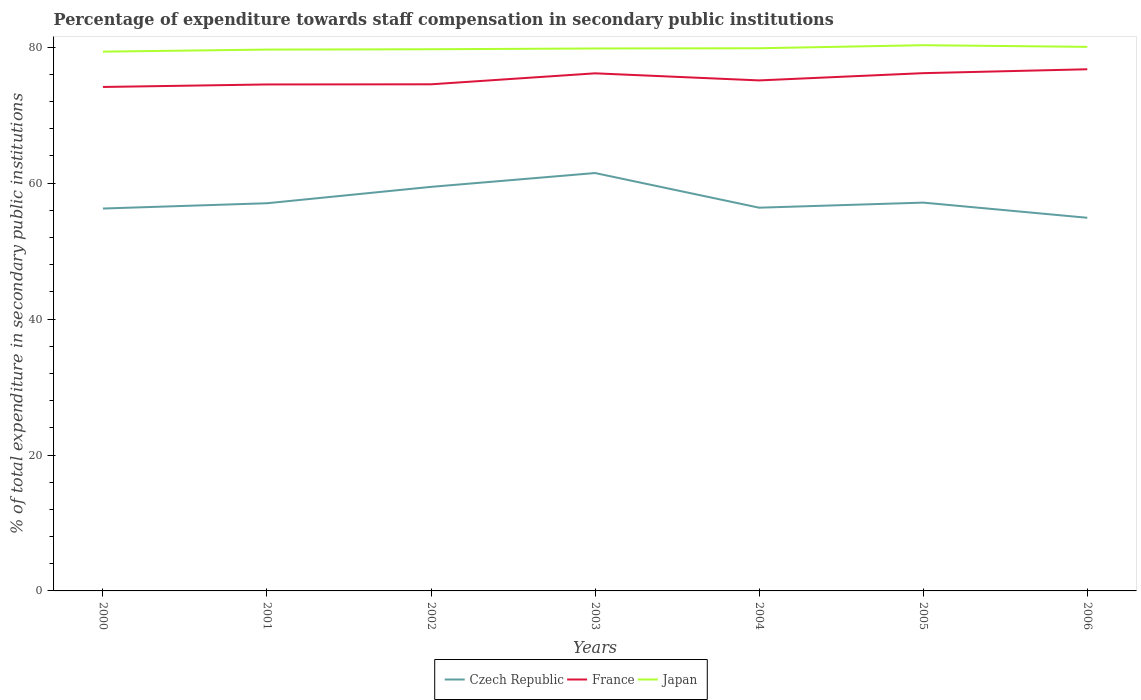Across all years, what is the maximum percentage of expenditure towards staff compensation in Japan?
Provide a short and direct response. 79.36. In which year was the percentage of expenditure towards staff compensation in Czech Republic maximum?
Offer a very short reply. 2006. What is the total percentage of expenditure towards staff compensation in Japan in the graph?
Keep it short and to the point. -0.5. What is the difference between the highest and the second highest percentage of expenditure towards staff compensation in Czech Republic?
Your response must be concise. 6.58. What is the difference between the highest and the lowest percentage of expenditure towards staff compensation in Czech Republic?
Provide a short and direct response. 2. Are the values on the major ticks of Y-axis written in scientific E-notation?
Offer a terse response. No. Does the graph contain any zero values?
Your answer should be very brief. No. Where does the legend appear in the graph?
Your answer should be compact. Bottom center. How are the legend labels stacked?
Provide a succinct answer. Horizontal. What is the title of the graph?
Make the answer very short. Percentage of expenditure towards staff compensation in secondary public institutions. What is the label or title of the Y-axis?
Your answer should be very brief. % of total expenditure in secondary public institutions. What is the % of total expenditure in secondary public institutions of Czech Republic in 2000?
Offer a terse response. 56.27. What is the % of total expenditure in secondary public institutions of France in 2000?
Your response must be concise. 74.16. What is the % of total expenditure in secondary public institutions in Japan in 2000?
Give a very brief answer. 79.36. What is the % of total expenditure in secondary public institutions of Czech Republic in 2001?
Keep it short and to the point. 57.05. What is the % of total expenditure in secondary public institutions in France in 2001?
Provide a succinct answer. 74.53. What is the % of total expenditure in secondary public institutions of Japan in 2001?
Provide a succinct answer. 79.66. What is the % of total expenditure in secondary public institutions of Czech Republic in 2002?
Keep it short and to the point. 59.46. What is the % of total expenditure in secondary public institutions in France in 2002?
Your answer should be compact. 74.55. What is the % of total expenditure in secondary public institutions in Japan in 2002?
Make the answer very short. 79.71. What is the % of total expenditure in secondary public institutions of Czech Republic in 2003?
Give a very brief answer. 61.49. What is the % of total expenditure in secondary public institutions of France in 2003?
Your answer should be compact. 76.16. What is the % of total expenditure in secondary public institutions of Japan in 2003?
Keep it short and to the point. 79.82. What is the % of total expenditure in secondary public institutions of Czech Republic in 2004?
Offer a terse response. 56.39. What is the % of total expenditure in secondary public institutions of France in 2004?
Offer a terse response. 75.12. What is the % of total expenditure in secondary public institutions in Japan in 2004?
Offer a terse response. 79.85. What is the % of total expenditure in secondary public institutions in Czech Republic in 2005?
Ensure brevity in your answer.  57.14. What is the % of total expenditure in secondary public institutions in France in 2005?
Your answer should be compact. 76.19. What is the % of total expenditure in secondary public institutions in Japan in 2005?
Provide a succinct answer. 80.3. What is the % of total expenditure in secondary public institutions of Czech Republic in 2006?
Your answer should be compact. 54.91. What is the % of total expenditure in secondary public institutions of France in 2006?
Make the answer very short. 76.76. What is the % of total expenditure in secondary public institutions in Japan in 2006?
Provide a short and direct response. 80.06. Across all years, what is the maximum % of total expenditure in secondary public institutions in Czech Republic?
Keep it short and to the point. 61.49. Across all years, what is the maximum % of total expenditure in secondary public institutions in France?
Offer a terse response. 76.76. Across all years, what is the maximum % of total expenditure in secondary public institutions of Japan?
Keep it short and to the point. 80.3. Across all years, what is the minimum % of total expenditure in secondary public institutions of Czech Republic?
Keep it short and to the point. 54.91. Across all years, what is the minimum % of total expenditure in secondary public institutions of France?
Your response must be concise. 74.16. Across all years, what is the minimum % of total expenditure in secondary public institutions of Japan?
Your response must be concise. 79.36. What is the total % of total expenditure in secondary public institutions of Czech Republic in the graph?
Your answer should be compact. 402.71. What is the total % of total expenditure in secondary public institutions in France in the graph?
Keep it short and to the point. 527.47. What is the total % of total expenditure in secondary public institutions in Japan in the graph?
Provide a short and direct response. 558.76. What is the difference between the % of total expenditure in secondary public institutions in Czech Republic in 2000 and that in 2001?
Give a very brief answer. -0.78. What is the difference between the % of total expenditure in secondary public institutions in France in 2000 and that in 2001?
Provide a short and direct response. -0.37. What is the difference between the % of total expenditure in secondary public institutions of Japan in 2000 and that in 2001?
Your answer should be compact. -0.3. What is the difference between the % of total expenditure in secondary public institutions in Czech Republic in 2000 and that in 2002?
Offer a terse response. -3.19. What is the difference between the % of total expenditure in secondary public institutions of France in 2000 and that in 2002?
Give a very brief answer. -0.39. What is the difference between the % of total expenditure in secondary public institutions of Japan in 2000 and that in 2002?
Provide a short and direct response. -0.35. What is the difference between the % of total expenditure in secondary public institutions in Czech Republic in 2000 and that in 2003?
Your answer should be compact. -5.22. What is the difference between the % of total expenditure in secondary public institutions in France in 2000 and that in 2003?
Keep it short and to the point. -2.01. What is the difference between the % of total expenditure in secondary public institutions in Japan in 2000 and that in 2003?
Ensure brevity in your answer.  -0.47. What is the difference between the % of total expenditure in secondary public institutions of Czech Republic in 2000 and that in 2004?
Your response must be concise. -0.12. What is the difference between the % of total expenditure in secondary public institutions of France in 2000 and that in 2004?
Your answer should be very brief. -0.97. What is the difference between the % of total expenditure in secondary public institutions in Japan in 2000 and that in 2004?
Your answer should be very brief. -0.5. What is the difference between the % of total expenditure in secondary public institutions in Czech Republic in 2000 and that in 2005?
Offer a very short reply. -0.87. What is the difference between the % of total expenditure in secondary public institutions of France in 2000 and that in 2005?
Ensure brevity in your answer.  -2.03. What is the difference between the % of total expenditure in secondary public institutions in Japan in 2000 and that in 2005?
Make the answer very short. -0.95. What is the difference between the % of total expenditure in secondary public institutions in Czech Republic in 2000 and that in 2006?
Offer a terse response. 1.36. What is the difference between the % of total expenditure in secondary public institutions of France in 2000 and that in 2006?
Your answer should be very brief. -2.6. What is the difference between the % of total expenditure in secondary public institutions of Japan in 2000 and that in 2006?
Ensure brevity in your answer.  -0.7. What is the difference between the % of total expenditure in secondary public institutions of Czech Republic in 2001 and that in 2002?
Make the answer very short. -2.41. What is the difference between the % of total expenditure in secondary public institutions of France in 2001 and that in 2002?
Your answer should be very brief. -0.02. What is the difference between the % of total expenditure in secondary public institutions in Japan in 2001 and that in 2002?
Give a very brief answer. -0.05. What is the difference between the % of total expenditure in secondary public institutions in Czech Republic in 2001 and that in 2003?
Your response must be concise. -4.45. What is the difference between the % of total expenditure in secondary public institutions of France in 2001 and that in 2003?
Your answer should be very brief. -1.64. What is the difference between the % of total expenditure in secondary public institutions of Japan in 2001 and that in 2003?
Provide a short and direct response. -0.16. What is the difference between the % of total expenditure in secondary public institutions in Czech Republic in 2001 and that in 2004?
Your answer should be very brief. 0.65. What is the difference between the % of total expenditure in secondary public institutions in France in 2001 and that in 2004?
Your answer should be very brief. -0.6. What is the difference between the % of total expenditure in secondary public institutions in Japan in 2001 and that in 2004?
Offer a very short reply. -0.19. What is the difference between the % of total expenditure in secondary public institutions in Czech Republic in 2001 and that in 2005?
Offer a terse response. -0.09. What is the difference between the % of total expenditure in secondary public institutions of France in 2001 and that in 2005?
Offer a very short reply. -1.66. What is the difference between the % of total expenditure in secondary public institutions of Japan in 2001 and that in 2005?
Provide a succinct answer. -0.64. What is the difference between the % of total expenditure in secondary public institutions in Czech Republic in 2001 and that in 2006?
Provide a succinct answer. 2.14. What is the difference between the % of total expenditure in secondary public institutions in France in 2001 and that in 2006?
Your answer should be compact. -2.24. What is the difference between the % of total expenditure in secondary public institutions of Japan in 2001 and that in 2006?
Offer a very short reply. -0.4. What is the difference between the % of total expenditure in secondary public institutions in Czech Republic in 2002 and that in 2003?
Provide a succinct answer. -2.04. What is the difference between the % of total expenditure in secondary public institutions of France in 2002 and that in 2003?
Ensure brevity in your answer.  -1.61. What is the difference between the % of total expenditure in secondary public institutions in Japan in 2002 and that in 2003?
Offer a very short reply. -0.11. What is the difference between the % of total expenditure in secondary public institutions in Czech Republic in 2002 and that in 2004?
Offer a terse response. 3.06. What is the difference between the % of total expenditure in secondary public institutions of France in 2002 and that in 2004?
Offer a very short reply. -0.57. What is the difference between the % of total expenditure in secondary public institutions in Japan in 2002 and that in 2004?
Offer a very short reply. -0.15. What is the difference between the % of total expenditure in secondary public institutions of Czech Republic in 2002 and that in 2005?
Make the answer very short. 2.32. What is the difference between the % of total expenditure in secondary public institutions in France in 2002 and that in 2005?
Provide a short and direct response. -1.64. What is the difference between the % of total expenditure in secondary public institutions of Japan in 2002 and that in 2005?
Your response must be concise. -0.59. What is the difference between the % of total expenditure in secondary public institutions of Czech Republic in 2002 and that in 2006?
Offer a very short reply. 4.55. What is the difference between the % of total expenditure in secondary public institutions in France in 2002 and that in 2006?
Keep it short and to the point. -2.21. What is the difference between the % of total expenditure in secondary public institutions of Japan in 2002 and that in 2006?
Ensure brevity in your answer.  -0.35. What is the difference between the % of total expenditure in secondary public institutions in France in 2003 and that in 2004?
Provide a succinct answer. 1.04. What is the difference between the % of total expenditure in secondary public institutions in Japan in 2003 and that in 2004?
Your answer should be very brief. -0.03. What is the difference between the % of total expenditure in secondary public institutions in Czech Republic in 2003 and that in 2005?
Offer a very short reply. 4.35. What is the difference between the % of total expenditure in secondary public institutions of France in 2003 and that in 2005?
Provide a succinct answer. -0.03. What is the difference between the % of total expenditure in secondary public institutions of Japan in 2003 and that in 2005?
Provide a short and direct response. -0.48. What is the difference between the % of total expenditure in secondary public institutions of Czech Republic in 2003 and that in 2006?
Your answer should be very brief. 6.58. What is the difference between the % of total expenditure in secondary public institutions in France in 2003 and that in 2006?
Offer a very short reply. -0.6. What is the difference between the % of total expenditure in secondary public institutions of Japan in 2003 and that in 2006?
Give a very brief answer. -0.24. What is the difference between the % of total expenditure in secondary public institutions of Czech Republic in 2004 and that in 2005?
Give a very brief answer. -0.75. What is the difference between the % of total expenditure in secondary public institutions of France in 2004 and that in 2005?
Your answer should be very brief. -1.07. What is the difference between the % of total expenditure in secondary public institutions of Japan in 2004 and that in 2005?
Make the answer very short. -0.45. What is the difference between the % of total expenditure in secondary public institutions of Czech Republic in 2004 and that in 2006?
Ensure brevity in your answer.  1.48. What is the difference between the % of total expenditure in secondary public institutions in France in 2004 and that in 2006?
Make the answer very short. -1.64. What is the difference between the % of total expenditure in secondary public institutions of Japan in 2004 and that in 2006?
Make the answer very short. -0.2. What is the difference between the % of total expenditure in secondary public institutions in Czech Republic in 2005 and that in 2006?
Provide a short and direct response. 2.23. What is the difference between the % of total expenditure in secondary public institutions of France in 2005 and that in 2006?
Keep it short and to the point. -0.57. What is the difference between the % of total expenditure in secondary public institutions in Japan in 2005 and that in 2006?
Your answer should be very brief. 0.24. What is the difference between the % of total expenditure in secondary public institutions of Czech Republic in 2000 and the % of total expenditure in secondary public institutions of France in 2001?
Provide a succinct answer. -18.26. What is the difference between the % of total expenditure in secondary public institutions in Czech Republic in 2000 and the % of total expenditure in secondary public institutions in Japan in 2001?
Your answer should be very brief. -23.39. What is the difference between the % of total expenditure in secondary public institutions in France in 2000 and the % of total expenditure in secondary public institutions in Japan in 2001?
Your answer should be compact. -5.5. What is the difference between the % of total expenditure in secondary public institutions in Czech Republic in 2000 and the % of total expenditure in secondary public institutions in France in 2002?
Offer a very short reply. -18.28. What is the difference between the % of total expenditure in secondary public institutions in Czech Republic in 2000 and the % of total expenditure in secondary public institutions in Japan in 2002?
Your response must be concise. -23.44. What is the difference between the % of total expenditure in secondary public institutions in France in 2000 and the % of total expenditure in secondary public institutions in Japan in 2002?
Make the answer very short. -5.55. What is the difference between the % of total expenditure in secondary public institutions in Czech Republic in 2000 and the % of total expenditure in secondary public institutions in France in 2003?
Offer a terse response. -19.9. What is the difference between the % of total expenditure in secondary public institutions in Czech Republic in 2000 and the % of total expenditure in secondary public institutions in Japan in 2003?
Offer a terse response. -23.55. What is the difference between the % of total expenditure in secondary public institutions of France in 2000 and the % of total expenditure in secondary public institutions of Japan in 2003?
Your answer should be very brief. -5.67. What is the difference between the % of total expenditure in secondary public institutions in Czech Republic in 2000 and the % of total expenditure in secondary public institutions in France in 2004?
Keep it short and to the point. -18.85. What is the difference between the % of total expenditure in secondary public institutions in Czech Republic in 2000 and the % of total expenditure in secondary public institutions in Japan in 2004?
Make the answer very short. -23.59. What is the difference between the % of total expenditure in secondary public institutions in France in 2000 and the % of total expenditure in secondary public institutions in Japan in 2004?
Make the answer very short. -5.7. What is the difference between the % of total expenditure in secondary public institutions of Czech Republic in 2000 and the % of total expenditure in secondary public institutions of France in 2005?
Ensure brevity in your answer.  -19.92. What is the difference between the % of total expenditure in secondary public institutions in Czech Republic in 2000 and the % of total expenditure in secondary public institutions in Japan in 2005?
Provide a succinct answer. -24.03. What is the difference between the % of total expenditure in secondary public institutions in France in 2000 and the % of total expenditure in secondary public institutions in Japan in 2005?
Your answer should be very brief. -6.14. What is the difference between the % of total expenditure in secondary public institutions of Czech Republic in 2000 and the % of total expenditure in secondary public institutions of France in 2006?
Give a very brief answer. -20.49. What is the difference between the % of total expenditure in secondary public institutions in Czech Republic in 2000 and the % of total expenditure in secondary public institutions in Japan in 2006?
Make the answer very short. -23.79. What is the difference between the % of total expenditure in secondary public institutions of France in 2000 and the % of total expenditure in secondary public institutions of Japan in 2006?
Your answer should be compact. -5.9. What is the difference between the % of total expenditure in secondary public institutions of Czech Republic in 2001 and the % of total expenditure in secondary public institutions of France in 2002?
Keep it short and to the point. -17.5. What is the difference between the % of total expenditure in secondary public institutions in Czech Republic in 2001 and the % of total expenditure in secondary public institutions in Japan in 2002?
Provide a succinct answer. -22.66. What is the difference between the % of total expenditure in secondary public institutions in France in 2001 and the % of total expenditure in secondary public institutions in Japan in 2002?
Offer a terse response. -5.18. What is the difference between the % of total expenditure in secondary public institutions of Czech Republic in 2001 and the % of total expenditure in secondary public institutions of France in 2003?
Keep it short and to the point. -19.12. What is the difference between the % of total expenditure in secondary public institutions of Czech Republic in 2001 and the % of total expenditure in secondary public institutions of Japan in 2003?
Offer a very short reply. -22.78. What is the difference between the % of total expenditure in secondary public institutions of France in 2001 and the % of total expenditure in secondary public institutions of Japan in 2003?
Ensure brevity in your answer.  -5.3. What is the difference between the % of total expenditure in secondary public institutions of Czech Republic in 2001 and the % of total expenditure in secondary public institutions of France in 2004?
Keep it short and to the point. -18.08. What is the difference between the % of total expenditure in secondary public institutions in Czech Republic in 2001 and the % of total expenditure in secondary public institutions in Japan in 2004?
Ensure brevity in your answer.  -22.81. What is the difference between the % of total expenditure in secondary public institutions of France in 2001 and the % of total expenditure in secondary public institutions of Japan in 2004?
Provide a succinct answer. -5.33. What is the difference between the % of total expenditure in secondary public institutions of Czech Republic in 2001 and the % of total expenditure in secondary public institutions of France in 2005?
Your answer should be very brief. -19.14. What is the difference between the % of total expenditure in secondary public institutions of Czech Republic in 2001 and the % of total expenditure in secondary public institutions of Japan in 2005?
Provide a succinct answer. -23.26. What is the difference between the % of total expenditure in secondary public institutions in France in 2001 and the % of total expenditure in secondary public institutions in Japan in 2005?
Keep it short and to the point. -5.78. What is the difference between the % of total expenditure in secondary public institutions of Czech Republic in 2001 and the % of total expenditure in secondary public institutions of France in 2006?
Your response must be concise. -19.72. What is the difference between the % of total expenditure in secondary public institutions in Czech Republic in 2001 and the % of total expenditure in secondary public institutions in Japan in 2006?
Make the answer very short. -23.01. What is the difference between the % of total expenditure in secondary public institutions in France in 2001 and the % of total expenditure in secondary public institutions in Japan in 2006?
Offer a terse response. -5.53. What is the difference between the % of total expenditure in secondary public institutions of Czech Republic in 2002 and the % of total expenditure in secondary public institutions of France in 2003?
Offer a terse response. -16.71. What is the difference between the % of total expenditure in secondary public institutions in Czech Republic in 2002 and the % of total expenditure in secondary public institutions in Japan in 2003?
Offer a terse response. -20.36. What is the difference between the % of total expenditure in secondary public institutions in France in 2002 and the % of total expenditure in secondary public institutions in Japan in 2003?
Give a very brief answer. -5.27. What is the difference between the % of total expenditure in secondary public institutions of Czech Republic in 2002 and the % of total expenditure in secondary public institutions of France in 2004?
Offer a terse response. -15.67. What is the difference between the % of total expenditure in secondary public institutions in Czech Republic in 2002 and the % of total expenditure in secondary public institutions in Japan in 2004?
Keep it short and to the point. -20.4. What is the difference between the % of total expenditure in secondary public institutions of France in 2002 and the % of total expenditure in secondary public institutions of Japan in 2004?
Offer a very short reply. -5.31. What is the difference between the % of total expenditure in secondary public institutions of Czech Republic in 2002 and the % of total expenditure in secondary public institutions of France in 2005?
Ensure brevity in your answer.  -16.73. What is the difference between the % of total expenditure in secondary public institutions of Czech Republic in 2002 and the % of total expenditure in secondary public institutions of Japan in 2005?
Provide a short and direct response. -20.84. What is the difference between the % of total expenditure in secondary public institutions of France in 2002 and the % of total expenditure in secondary public institutions of Japan in 2005?
Provide a succinct answer. -5.75. What is the difference between the % of total expenditure in secondary public institutions in Czech Republic in 2002 and the % of total expenditure in secondary public institutions in France in 2006?
Your response must be concise. -17.3. What is the difference between the % of total expenditure in secondary public institutions of Czech Republic in 2002 and the % of total expenditure in secondary public institutions of Japan in 2006?
Make the answer very short. -20.6. What is the difference between the % of total expenditure in secondary public institutions in France in 2002 and the % of total expenditure in secondary public institutions in Japan in 2006?
Provide a succinct answer. -5.51. What is the difference between the % of total expenditure in secondary public institutions of Czech Republic in 2003 and the % of total expenditure in secondary public institutions of France in 2004?
Make the answer very short. -13.63. What is the difference between the % of total expenditure in secondary public institutions of Czech Republic in 2003 and the % of total expenditure in secondary public institutions of Japan in 2004?
Make the answer very short. -18.36. What is the difference between the % of total expenditure in secondary public institutions of France in 2003 and the % of total expenditure in secondary public institutions of Japan in 2004?
Provide a succinct answer. -3.69. What is the difference between the % of total expenditure in secondary public institutions in Czech Republic in 2003 and the % of total expenditure in secondary public institutions in France in 2005?
Your answer should be compact. -14.7. What is the difference between the % of total expenditure in secondary public institutions in Czech Republic in 2003 and the % of total expenditure in secondary public institutions in Japan in 2005?
Your answer should be compact. -18.81. What is the difference between the % of total expenditure in secondary public institutions in France in 2003 and the % of total expenditure in secondary public institutions in Japan in 2005?
Ensure brevity in your answer.  -4.14. What is the difference between the % of total expenditure in secondary public institutions in Czech Republic in 2003 and the % of total expenditure in secondary public institutions in France in 2006?
Give a very brief answer. -15.27. What is the difference between the % of total expenditure in secondary public institutions in Czech Republic in 2003 and the % of total expenditure in secondary public institutions in Japan in 2006?
Offer a very short reply. -18.57. What is the difference between the % of total expenditure in secondary public institutions in France in 2003 and the % of total expenditure in secondary public institutions in Japan in 2006?
Provide a succinct answer. -3.89. What is the difference between the % of total expenditure in secondary public institutions in Czech Republic in 2004 and the % of total expenditure in secondary public institutions in France in 2005?
Offer a very short reply. -19.8. What is the difference between the % of total expenditure in secondary public institutions in Czech Republic in 2004 and the % of total expenditure in secondary public institutions in Japan in 2005?
Give a very brief answer. -23.91. What is the difference between the % of total expenditure in secondary public institutions in France in 2004 and the % of total expenditure in secondary public institutions in Japan in 2005?
Keep it short and to the point. -5.18. What is the difference between the % of total expenditure in secondary public institutions in Czech Republic in 2004 and the % of total expenditure in secondary public institutions in France in 2006?
Provide a short and direct response. -20.37. What is the difference between the % of total expenditure in secondary public institutions of Czech Republic in 2004 and the % of total expenditure in secondary public institutions of Japan in 2006?
Provide a short and direct response. -23.67. What is the difference between the % of total expenditure in secondary public institutions in France in 2004 and the % of total expenditure in secondary public institutions in Japan in 2006?
Ensure brevity in your answer.  -4.94. What is the difference between the % of total expenditure in secondary public institutions in Czech Republic in 2005 and the % of total expenditure in secondary public institutions in France in 2006?
Your answer should be compact. -19.62. What is the difference between the % of total expenditure in secondary public institutions in Czech Republic in 2005 and the % of total expenditure in secondary public institutions in Japan in 2006?
Give a very brief answer. -22.92. What is the difference between the % of total expenditure in secondary public institutions of France in 2005 and the % of total expenditure in secondary public institutions of Japan in 2006?
Ensure brevity in your answer.  -3.87. What is the average % of total expenditure in secondary public institutions in Czech Republic per year?
Keep it short and to the point. 57.53. What is the average % of total expenditure in secondary public institutions of France per year?
Your response must be concise. 75.35. What is the average % of total expenditure in secondary public institutions of Japan per year?
Provide a succinct answer. 79.82. In the year 2000, what is the difference between the % of total expenditure in secondary public institutions in Czech Republic and % of total expenditure in secondary public institutions in France?
Offer a very short reply. -17.89. In the year 2000, what is the difference between the % of total expenditure in secondary public institutions of Czech Republic and % of total expenditure in secondary public institutions of Japan?
Provide a short and direct response. -23.09. In the year 2000, what is the difference between the % of total expenditure in secondary public institutions in France and % of total expenditure in secondary public institutions in Japan?
Make the answer very short. -5.2. In the year 2001, what is the difference between the % of total expenditure in secondary public institutions in Czech Republic and % of total expenditure in secondary public institutions in France?
Give a very brief answer. -17.48. In the year 2001, what is the difference between the % of total expenditure in secondary public institutions in Czech Republic and % of total expenditure in secondary public institutions in Japan?
Your response must be concise. -22.61. In the year 2001, what is the difference between the % of total expenditure in secondary public institutions in France and % of total expenditure in secondary public institutions in Japan?
Your answer should be very brief. -5.13. In the year 2002, what is the difference between the % of total expenditure in secondary public institutions in Czech Republic and % of total expenditure in secondary public institutions in France?
Make the answer very short. -15.09. In the year 2002, what is the difference between the % of total expenditure in secondary public institutions in Czech Republic and % of total expenditure in secondary public institutions in Japan?
Offer a very short reply. -20.25. In the year 2002, what is the difference between the % of total expenditure in secondary public institutions in France and % of total expenditure in secondary public institutions in Japan?
Offer a terse response. -5.16. In the year 2003, what is the difference between the % of total expenditure in secondary public institutions in Czech Republic and % of total expenditure in secondary public institutions in France?
Offer a very short reply. -14.67. In the year 2003, what is the difference between the % of total expenditure in secondary public institutions in Czech Republic and % of total expenditure in secondary public institutions in Japan?
Keep it short and to the point. -18.33. In the year 2003, what is the difference between the % of total expenditure in secondary public institutions in France and % of total expenditure in secondary public institutions in Japan?
Make the answer very short. -3.66. In the year 2004, what is the difference between the % of total expenditure in secondary public institutions in Czech Republic and % of total expenditure in secondary public institutions in France?
Provide a succinct answer. -18.73. In the year 2004, what is the difference between the % of total expenditure in secondary public institutions in Czech Republic and % of total expenditure in secondary public institutions in Japan?
Offer a very short reply. -23.46. In the year 2004, what is the difference between the % of total expenditure in secondary public institutions in France and % of total expenditure in secondary public institutions in Japan?
Your answer should be very brief. -4.73. In the year 2005, what is the difference between the % of total expenditure in secondary public institutions of Czech Republic and % of total expenditure in secondary public institutions of France?
Make the answer very short. -19.05. In the year 2005, what is the difference between the % of total expenditure in secondary public institutions in Czech Republic and % of total expenditure in secondary public institutions in Japan?
Provide a succinct answer. -23.16. In the year 2005, what is the difference between the % of total expenditure in secondary public institutions of France and % of total expenditure in secondary public institutions of Japan?
Your answer should be very brief. -4.11. In the year 2006, what is the difference between the % of total expenditure in secondary public institutions of Czech Republic and % of total expenditure in secondary public institutions of France?
Your answer should be very brief. -21.85. In the year 2006, what is the difference between the % of total expenditure in secondary public institutions of Czech Republic and % of total expenditure in secondary public institutions of Japan?
Make the answer very short. -25.15. In the year 2006, what is the difference between the % of total expenditure in secondary public institutions of France and % of total expenditure in secondary public institutions of Japan?
Your answer should be very brief. -3.3. What is the ratio of the % of total expenditure in secondary public institutions in Czech Republic in 2000 to that in 2001?
Your answer should be very brief. 0.99. What is the ratio of the % of total expenditure in secondary public institutions in France in 2000 to that in 2001?
Keep it short and to the point. 1. What is the ratio of the % of total expenditure in secondary public institutions of Czech Republic in 2000 to that in 2002?
Give a very brief answer. 0.95. What is the ratio of the % of total expenditure in secondary public institutions in Czech Republic in 2000 to that in 2003?
Give a very brief answer. 0.92. What is the ratio of the % of total expenditure in secondary public institutions of France in 2000 to that in 2003?
Provide a succinct answer. 0.97. What is the ratio of the % of total expenditure in secondary public institutions in Japan in 2000 to that in 2003?
Give a very brief answer. 0.99. What is the ratio of the % of total expenditure in secondary public institutions of France in 2000 to that in 2004?
Provide a succinct answer. 0.99. What is the ratio of the % of total expenditure in secondary public institutions in Japan in 2000 to that in 2004?
Ensure brevity in your answer.  0.99. What is the ratio of the % of total expenditure in secondary public institutions in Czech Republic in 2000 to that in 2005?
Offer a very short reply. 0.98. What is the ratio of the % of total expenditure in secondary public institutions of France in 2000 to that in 2005?
Provide a succinct answer. 0.97. What is the ratio of the % of total expenditure in secondary public institutions in Japan in 2000 to that in 2005?
Make the answer very short. 0.99. What is the ratio of the % of total expenditure in secondary public institutions of Czech Republic in 2000 to that in 2006?
Keep it short and to the point. 1.02. What is the ratio of the % of total expenditure in secondary public institutions of France in 2000 to that in 2006?
Your response must be concise. 0.97. What is the ratio of the % of total expenditure in secondary public institutions of Japan in 2000 to that in 2006?
Make the answer very short. 0.99. What is the ratio of the % of total expenditure in secondary public institutions in Czech Republic in 2001 to that in 2002?
Make the answer very short. 0.96. What is the ratio of the % of total expenditure in secondary public institutions in Czech Republic in 2001 to that in 2003?
Provide a succinct answer. 0.93. What is the ratio of the % of total expenditure in secondary public institutions of France in 2001 to that in 2003?
Ensure brevity in your answer.  0.98. What is the ratio of the % of total expenditure in secondary public institutions in Czech Republic in 2001 to that in 2004?
Offer a terse response. 1.01. What is the ratio of the % of total expenditure in secondary public institutions of Czech Republic in 2001 to that in 2005?
Offer a very short reply. 1. What is the ratio of the % of total expenditure in secondary public institutions of France in 2001 to that in 2005?
Offer a terse response. 0.98. What is the ratio of the % of total expenditure in secondary public institutions in Japan in 2001 to that in 2005?
Make the answer very short. 0.99. What is the ratio of the % of total expenditure in secondary public institutions in Czech Republic in 2001 to that in 2006?
Your answer should be very brief. 1.04. What is the ratio of the % of total expenditure in secondary public institutions of France in 2001 to that in 2006?
Your response must be concise. 0.97. What is the ratio of the % of total expenditure in secondary public institutions in Japan in 2001 to that in 2006?
Offer a terse response. 0.99. What is the ratio of the % of total expenditure in secondary public institutions in Czech Republic in 2002 to that in 2003?
Provide a short and direct response. 0.97. What is the ratio of the % of total expenditure in secondary public institutions in France in 2002 to that in 2003?
Your answer should be compact. 0.98. What is the ratio of the % of total expenditure in secondary public institutions of Japan in 2002 to that in 2003?
Your response must be concise. 1. What is the ratio of the % of total expenditure in secondary public institutions in Czech Republic in 2002 to that in 2004?
Ensure brevity in your answer.  1.05. What is the ratio of the % of total expenditure in secondary public institutions in Czech Republic in 2002 to that in 2005?
Offer a terse response. 1.04. What is the ratio of the % of total expenditure in secondary public institutions of France in 2002 to that in 2005?
Provide a succinct answer. 0.98. What is the ratio of the % of total expenditure in secondary public institutions of Czech Republic in 2002 to that in 2006?
Provide a succinct answer. 1.08. What is the ratio of the % of total expenditure in secondary public institutions of France in 2002 to that in 2006?
Make the answer very short. 0.97. What is the ratio of the % of total expenditure in secondary public institutions of Japan in 2002 to that in 2006?
Offer a terse response. 1. What is the ratio of the % of total expenditure in secondary public institutions in Czech Republic in 2003 to that in 2004?
Offer a terse response. 1.09. What is the ratio of the % of total expenditure in secondary public institutions of France in 2003 to that in 2004?
Give a very brief answer. 1.01. What is the ratio of the % of total expenditure in secondary public institutions of Japan in 2003 to that in 2004?
Your response must be concise. 1. What is the ratio of the % of total expenditure in secondary public institutions of Czech Republic in 2003 to that in 2005?
Your response must be concise. 1.08. What is the ratio of the % of total expenditure in secondary public institutions in France in 2003 to that in 2005?
Your answer should be compact. 1. What is the ratio of the % of total expenditure in secondary public institutions of Czech Republic in 2003 to that in 2006?
Your answer should be compact. 1.12. What is the ratio of the % of total expenditure in secondary public institutions in France in 2003 to that in 2006?
Give a very brief answer. 0.99. What is the ratio of the % of total expenditure in secondary public institutions of Japan in 2003 to that in 2006?
Your answer should be compact. 1. What is the ratio of the % of total expenditure in secondary public institutions of Czech Republic in 2004 to that in 2005?
Ensure brevity in your answer.  0.99. What is the ratio of the % of total expenditure in secondary public institutions in France in 2004 to that in 2005?
Keep it short and to the point. 0.99. What is the ratio of the % of total expenditure in secondary public institutions of Czech Republic in 2004 to that in 2006?
Offer a terse response. 1.03. What is the ratio of the % of total expenditure in secondary public institutions of France in 2004 to that in 2006?
Keep it short and to the point. 0.98. What is the ratio of the % of total expenditure in secondary public institutions in Japan in 2004 to that in 2006?
Provide a succinct answer. 1. What is the ratio of the % of total expenditure in secondary public institutions of Czech Republic in 2005 to that in 2006?
Your response must be concise. 1.04. What is the difference between the highest and the second highest % of total expenditure in secondary public institutions of Czech Republic?
Give a very brief answer. 2.04. What is the difference between the highest and the second highest % of total expenditure in secondary public institutions in France?
Ensure brevity in your answer.  0.57. What is the difference between the highest and the second highest % of total expenditure in secondary public institutions in Japan?
Offer a terse response. 0.24. What is the difference between the highest and the lowest % of total expenditure in secondary public institutions of Czech Republic?
Provide a short and direct response. 6.58. What is the difference between the highest and the lowest % of total expenditure in secondary public institutions in France?
Make the answer very short. 2.6. What is the difference between the highest and the lowest % of total expenditure in secondary public institutions of Japan?
Your answer should be compact. 0.95. 